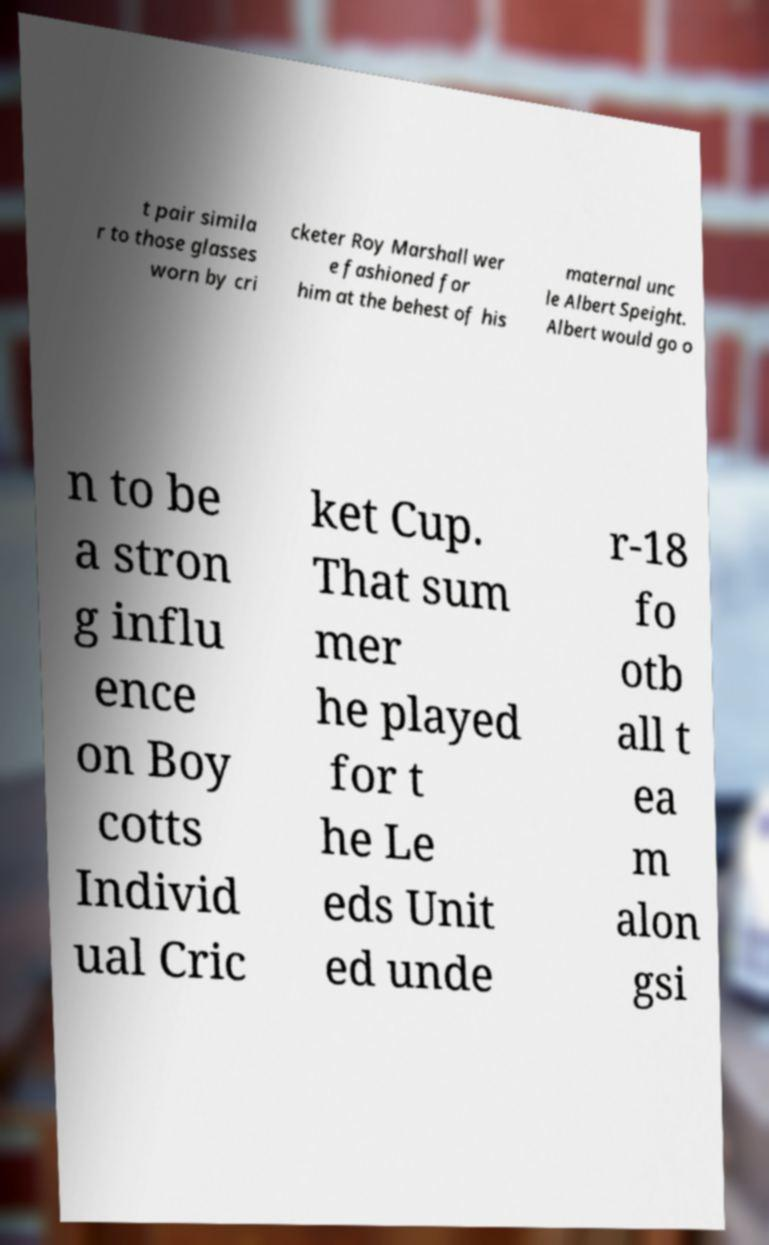There's text embedded in this image that I need extracted. Can you transcribe it verbatim? t pair simila r to those glasses worn by cri cketer Roy Marshall wer e fashioned for him at the behest of his maternal unc le Albert Speight. Albert would go o n to be a stron g influ ence on Boy cotts Individ ual Cric ket Cup. That sum mer he played for t he Le eds Unit ed unde r-18 fo otb all t ea m alon gsi 